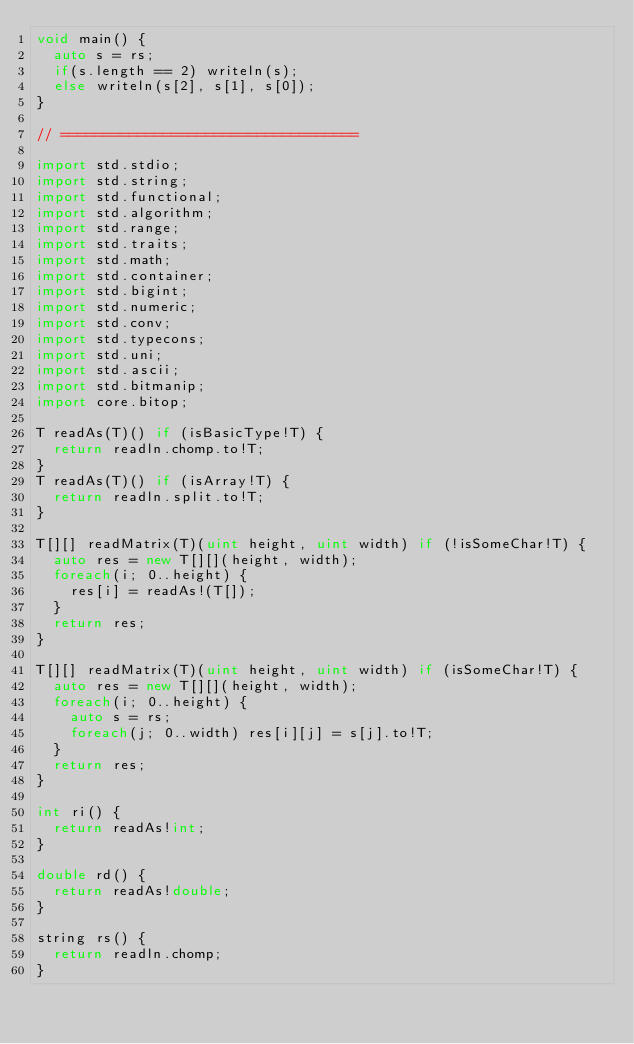Convert code to text. <code><loc_0><loc_0><loc_500><loc_500><_D_>void main() {
	auto s = rs;
	if(s.length == 2) writeln(s);
	else writeln(s[2], s[1], s[0]);
}

// ===================================

import std.stdio;
import std.string;
import std.functional;
import std.algorithm;
import std.range;
import std.traits;
import std.math;
import std.container;
import std.bigint;
import std.numeric;
import std.conv;
import std.typecons;
import std.uni;
import std.ascii;
import std.bitmanip;
import core.bitop;

T readAs(T)() if (isBasicType!T) {
	return readln.chomp.to!T;
}
T readAs(T)() if (isArray!T) {
	return readln.split.to!T;
}

T[][] readMatrix(T)(uint height, uint width) if (!isSomeChar!T) {
	auto res = new T[][](height, width);
	foreach(i; 0..height) {
		res[i] = readAs!(T[]);
	}
	return res;
}

T[][] readMatrix(T)(uint height, uint width) if (isSomeChar!T) {
	auto res = new T[][](height, width);
	foreach(i; 0..height) {
		auto s = rs;
		foreach(j; 0..width) res[i][j] = s[j].to!T;
	}
	return res;
}

int ri() {
	return readAs!int;
}

double rd() {
	return readAs!double;
}

string rs() {
	return readln.chomp;
}</code> 